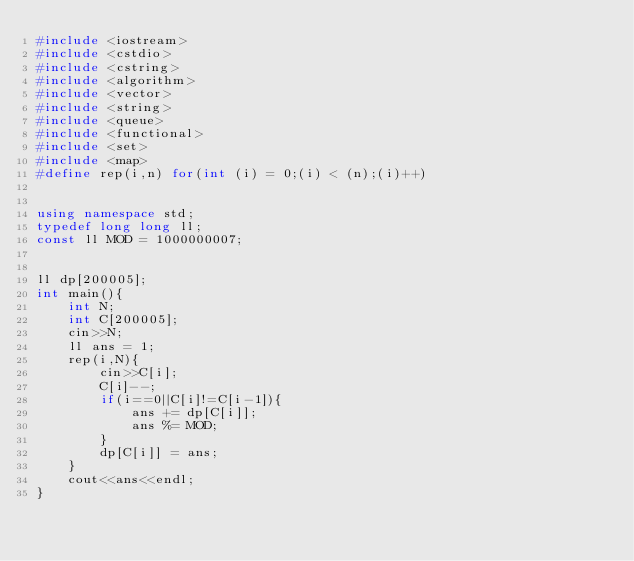Convert code to text. <code><loc_0><loc_0><loc_500><loc_500><_C++_>#include <iostream>
#include <cstdio>
#include <cstring>
#include <algorithm>
#include <vector>
#include <string>
#include <queue>
#include <functional>
#include <set>
#include <map>
#define rep(i,n) for(int (i) = 0;(i) < (n);(i)++)


using namespace std;
typedef long long ll;
const ll MOD = 1000000007;


ll dp[200005];
int main(){
    int N;
    int C[200005];
    cin>>N;
    ll ans = 1;
    rep(i,N){
        cin>>C[i];
        C[i]--;
        if(i==0||C[i]!=C[i-1]){
            ans += dp[C[i]];
            ans %= MOD;
        }
        dp[C[i]] = ans;
    }
    cout<<ans<<endl;
}
</code> 